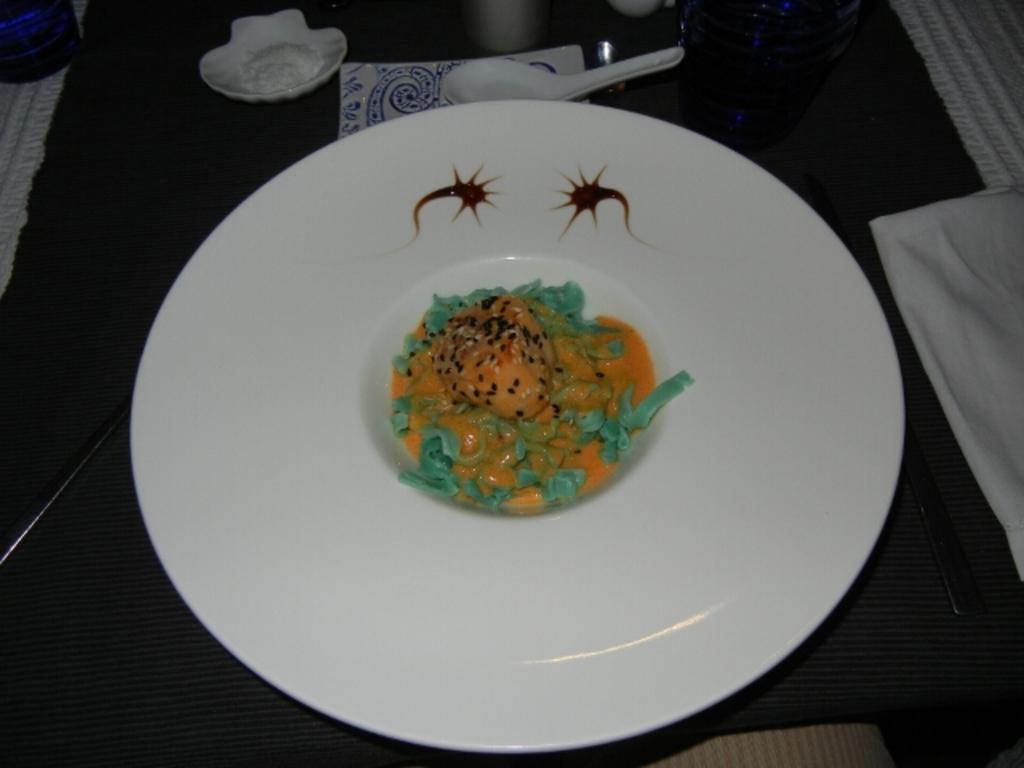What is on the white plate in the image? There is a food item on the white plate in the image. What utensil is visible in the image? There is a spoon visible in the image. What else can be seen on the table in the image? There are other objects on the table in the image. Can you describe the sheep's eye in the image? There are no sheep or eyes present in the image; it features a white plate with a food item and a spoon on a table with other objects. 